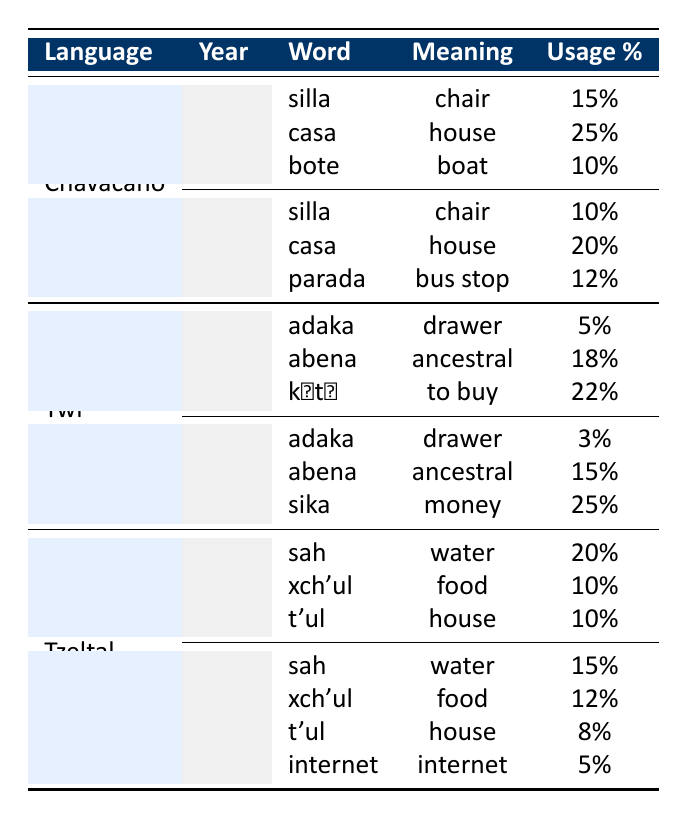What is the usage percentage of the word "casa" in Chavacano in 1990? In the table under the Chavacano language for the year 1990, the word "casa" has a usage percentage of 25%.
Answer: 25% What new word was introduced in the Chavacano vocabulary by 2020? By 2020, the Chavacano vocabulary introduced the word "parada," meaning "bus stop," which was not present in 1990.
Answer: parada Which language saw the highest percentage increase in usage for any word from 1990 to 2020? Looking at the Twi language, "sika," meaning "money," increased from 0% presence before 2020 (not listed in 1990) to 25% in 2020, indicating a 25% increase. Comparing it to others like "sah" in Tzeltal, which decreased, "sika" has the highest increase.
Answer: sika Is the meaning of the word "sah" consistent between 1990 and 2020 in Tzeltal? The meaning of the word "sah" remains "water" in both 1990 and 2020, which confirms its consistency over the time period considered.
Answer: Yes What is the average usage percentage for the listed words in Twi for the year 2020? The usage percentages for Twi in 2020 are 3% for "adaka," 15% for "abena," and 25% for "sika." Adding these gives 3 + 15 + 25 = 43. Dividing by the number of words (3) gives an average of 43 / 3 = 14.33, approximately 14.3%.
Answer: 14.3% 